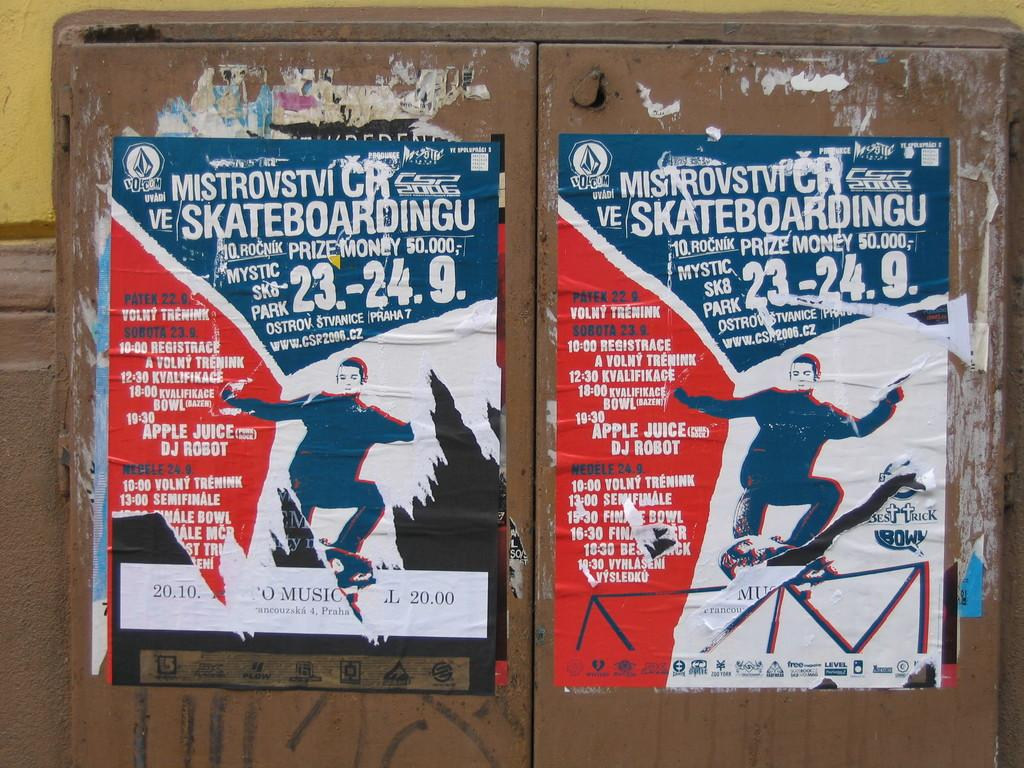What type of wooden object has posts on it in the image? The fact does not specify the type of wooden object, but there are posts on a wooden object in the image. What is located behind the wooden object with posts? There is a wall in the image. What can be read on the posters in the image? There is text visible on the posters. Is there a cup and kettle being used for a competition in the image? There is no mention of a cup, kettle, or competition in the image. 